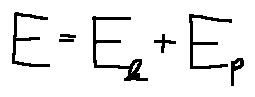<formula> <loc_0><loc_0><loc_500><loc_500>E = E _ { k } + E _ { p }</formula> 